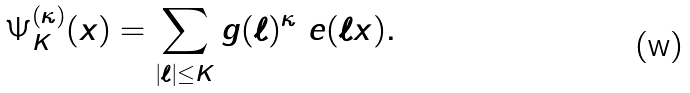Convert formula to latex. <formula><loc_0><loc_0><loc_500><loc_500>\Psi _ { K } ^ { ( \kappa ) } ( x ) = \sum _ { | \ell | \leq K } g ( \ell ) ^ { \kappa } \ e ( \ell x ) .</formula> 